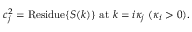<formula> <loc_0><loc_0><loc_500><loc_500>c _ { j } ^ { 2 } = R e s i d u e \{ S ( k ) \} a t k = i \kappa _ { j } ( \kappa _ { i } > 0 ) .</formula> 